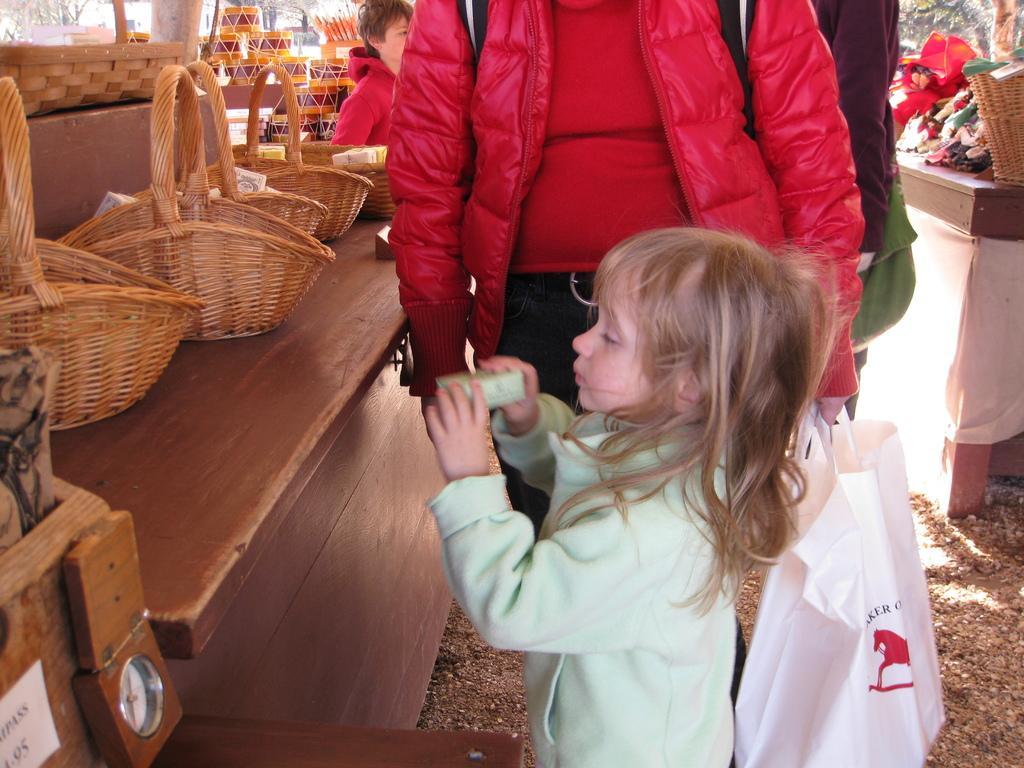Can you describe this image briefly? In the image we can see there are people who are standing on the floor and the person is holding a white plastic cover and wearing red colour jacket and on table there are baskets. 